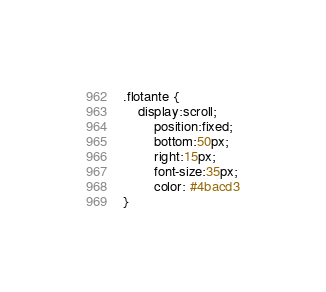<code> <loc_0><loc_0><loc_500><loc_500><_CSS_>

.flotante {
    display:scroll;
        position:fixed;
        bottom:50px;
        right:15px;
        font-size:35px;
        color: #4bacd3
}</code> 